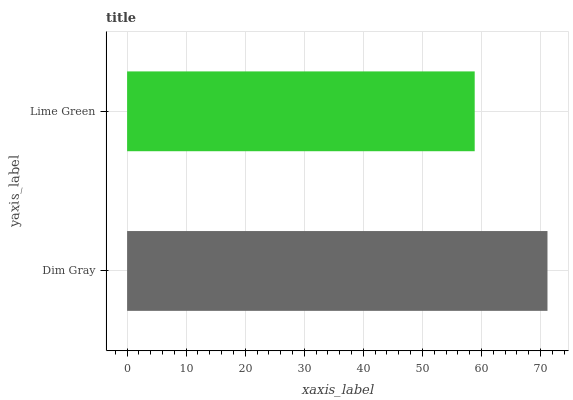Is Lime Green the minimum?
Answer yes or no. Yes. Is Dim Gray the maximum?
Answer yes or no. Yes. Is Lime Green the maximum?
Answer yes or no. No. Is Dim Gray greater than Lime Green?
Answer yes or no. Yes. Is Lime Green less than Dim Gray?
Answer yes or no. Yes. Is Lime Green greater than Dim Gray?
Answer yes or no. No. Is Dim Gray less than Lime Green?
Answer yes or no. No. Is Dim Gray the high median?
Answer yes or no. Yes. Is Lime Green the low median?
Answer yes or no. Yes. Is Lime Green the high median?
Answer yes or no. No. Is Dim Gray the low median?
Answer yes or no. No. 